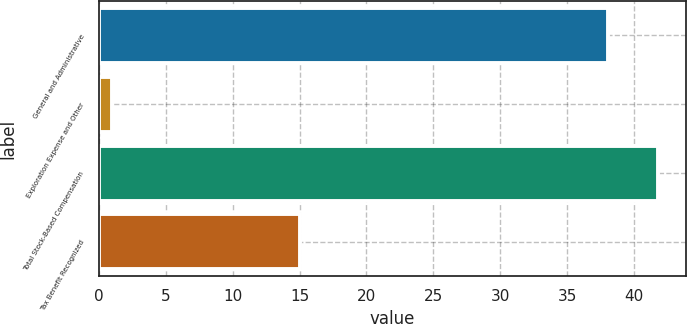Convert chart. <chart><loc_0><loc_0><loc_500><loc_500><bar_chart><fcel>General and Administrative<fcel>Exploration Expense and Other<fcel>Total Stock-Based Compensation<fcel>Tax Benefit Recognized<nl><fcel>38<fcel>1<fcel>41.8<fcel>15<nl></chart> 